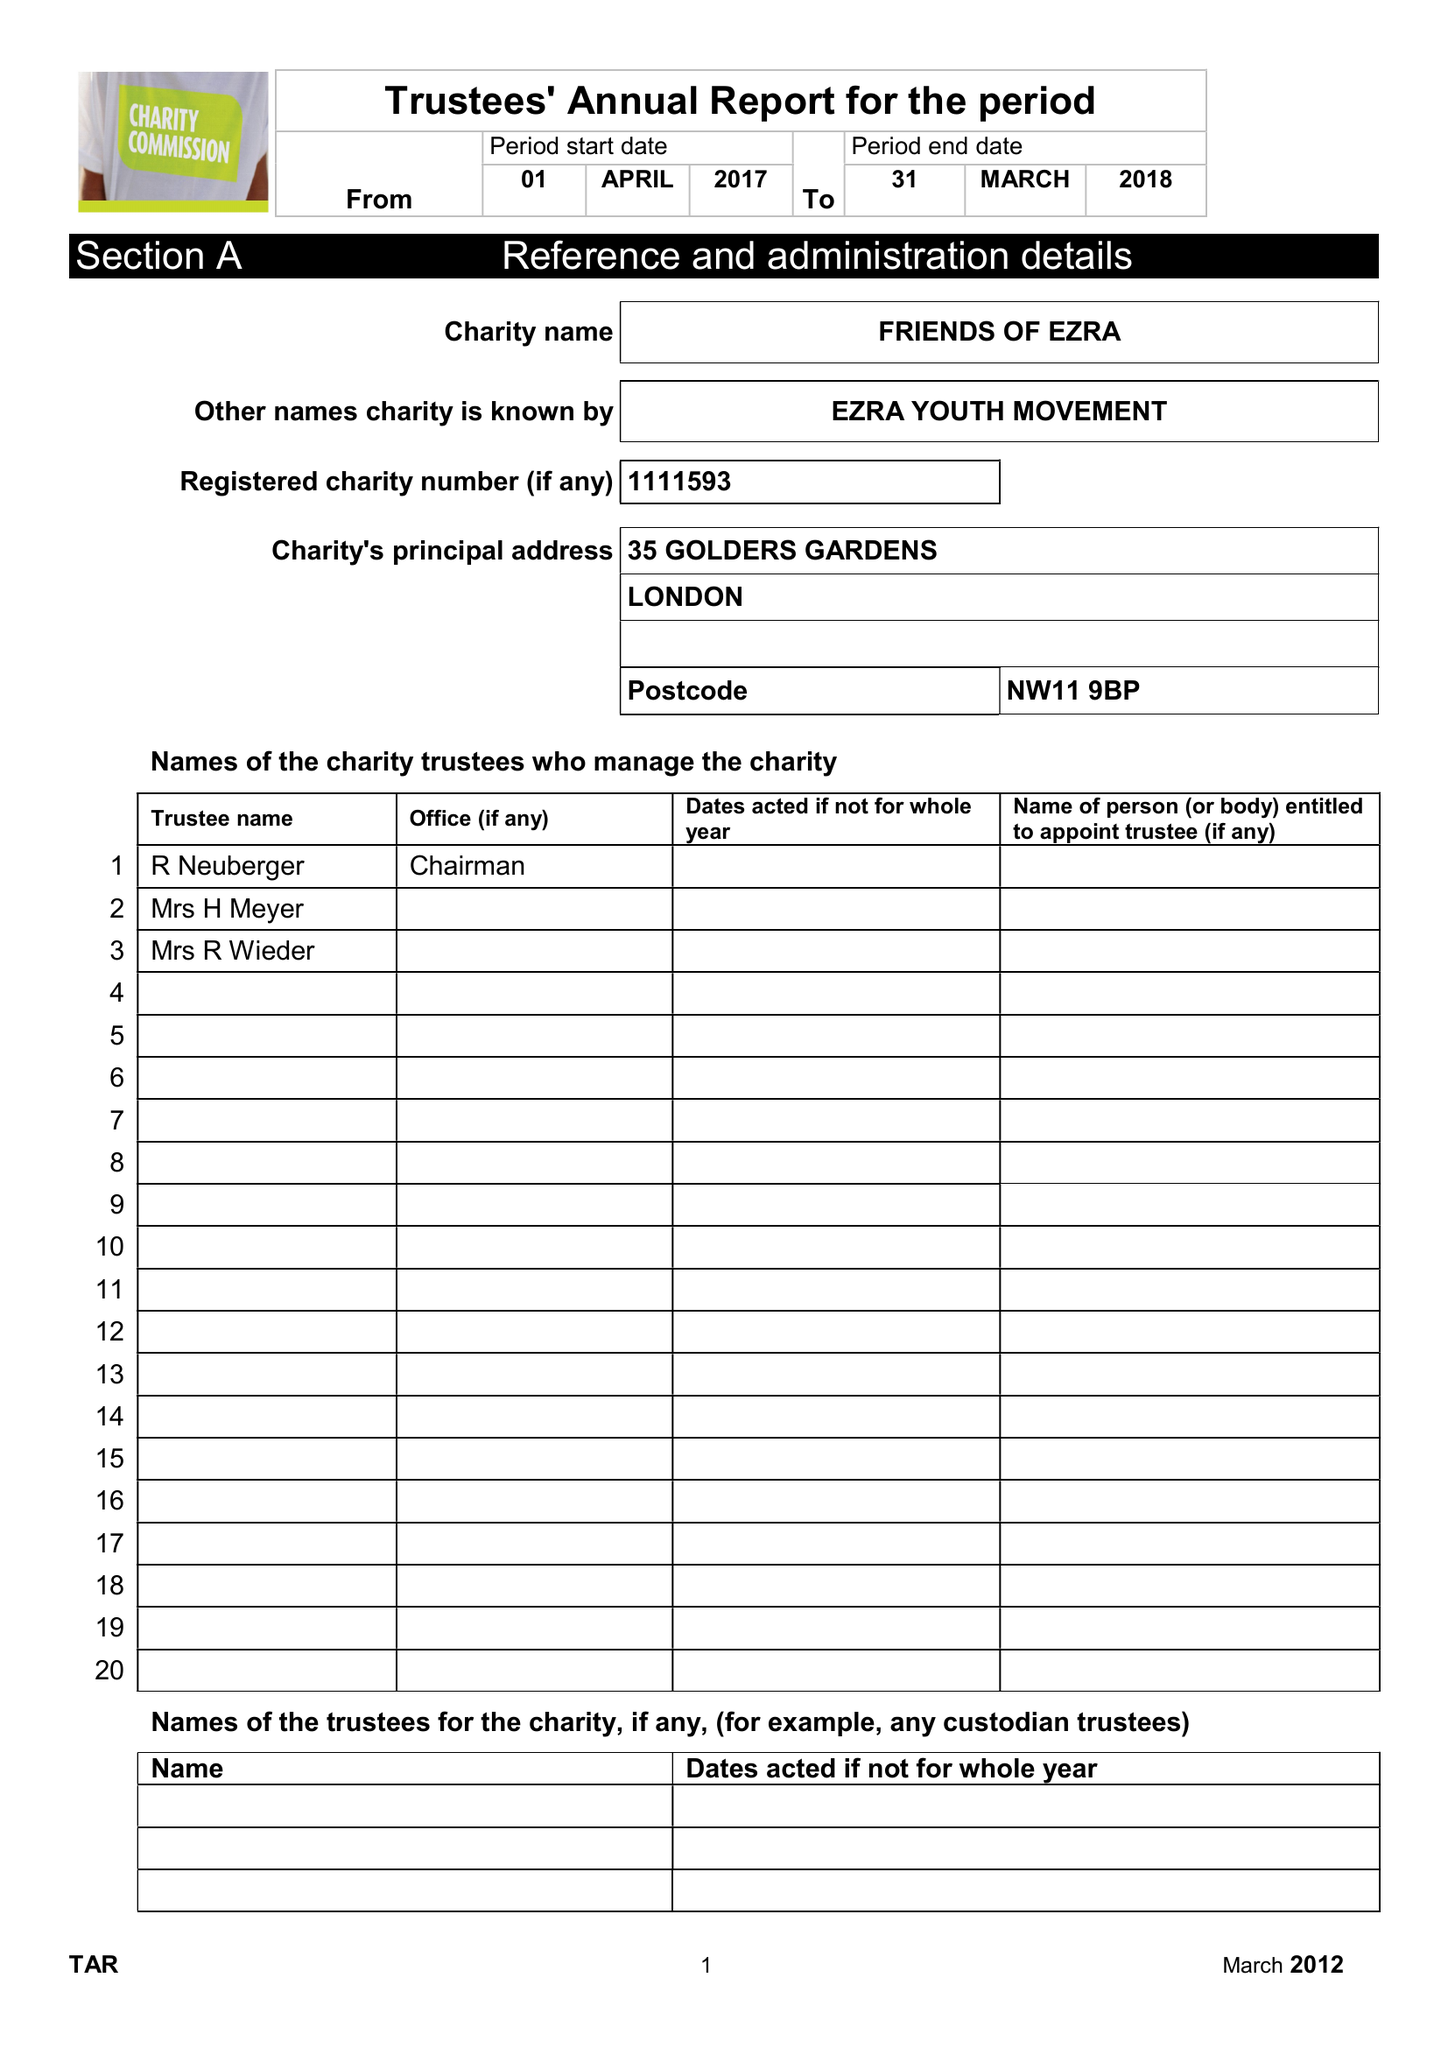What is the value for the address__post_town?
Answer the question using a single word or phrase. LONDON 